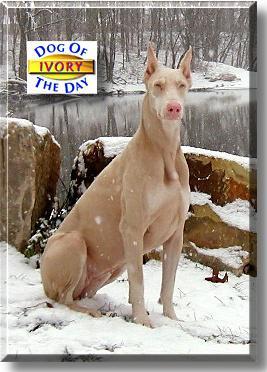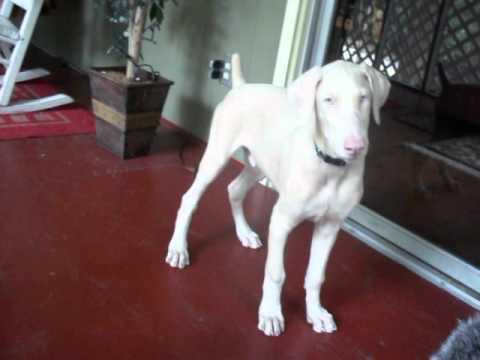The first image is the image on the left, the second image is the image on the right. For the images shown, is this caption "There are two dogs with the tips of their ears pointed up" true? Answer yes or no. No. The first image is the image on the left, the second image is the image on the right. For the images displayed, is the sentence "The ears of the dog in one of the images are down." factually correct? Answer yes or no. Yes. 